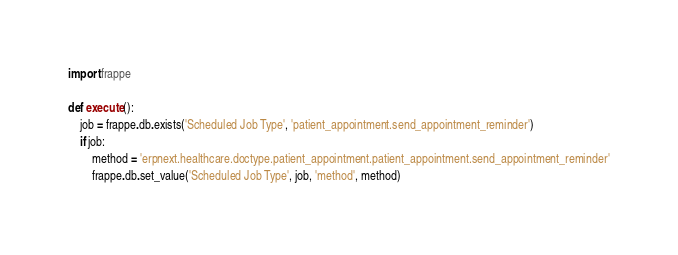<code> <loc_0><loc_0><loc_500><loc_500><_Python_>import frappe

def execute():
	job = frappe.db.exists('Scheduled Job Type', 'patient_appointment.send_appointment_reminder')
	if job:
		method = 'erpnext.healthcare.doctype.patient_appointment.patient_appointment.send_appointment_reminder'
		frappe.db.set_value('Scheduled Job Type', job, 'method', method)</code> 